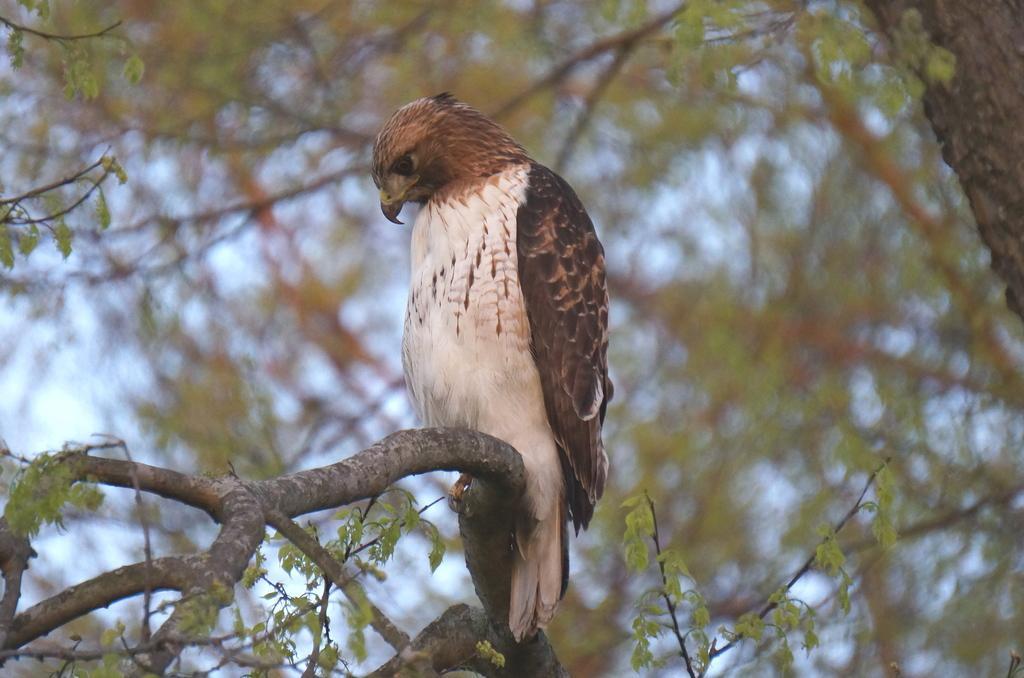Can you describe this image briefly? In this image we can see a bird sitting on a branch of the tree. There is a tree in the image. There is a blur background in the image. 